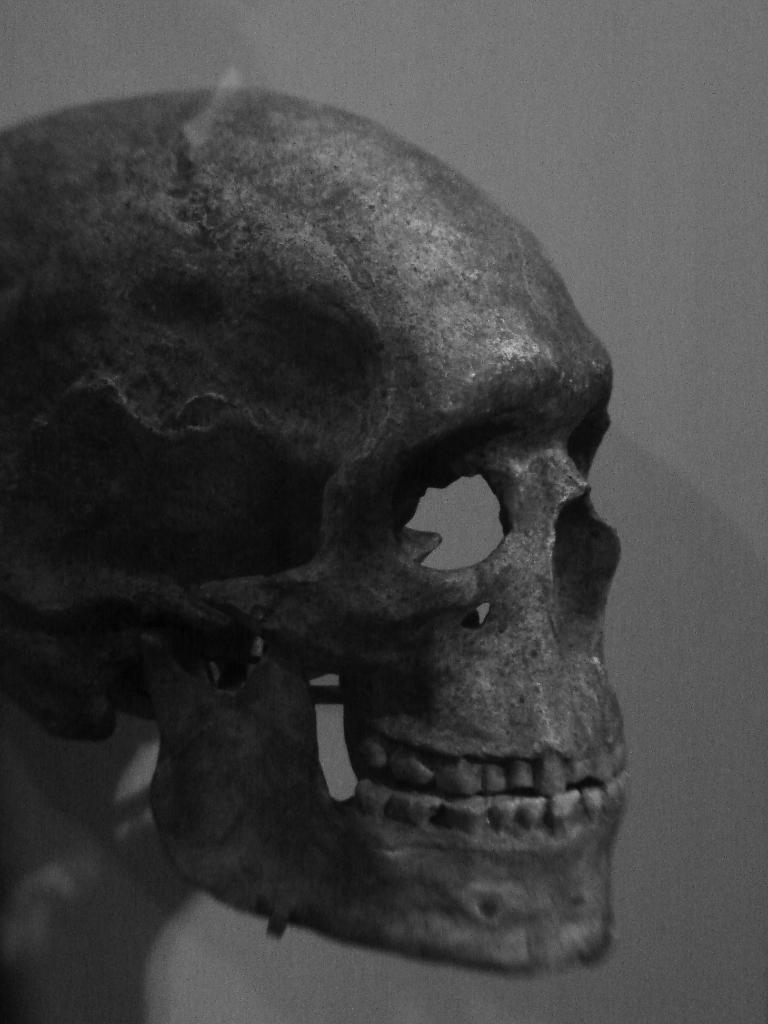What is the main subject of the image? The main subject of the image is a skull. Can you describe the background of the image? The background of the image is ash-colored. What type of whip is being used by the person in the image? There is no person or whip present in the image; it features a skull and an ash-colored background. 